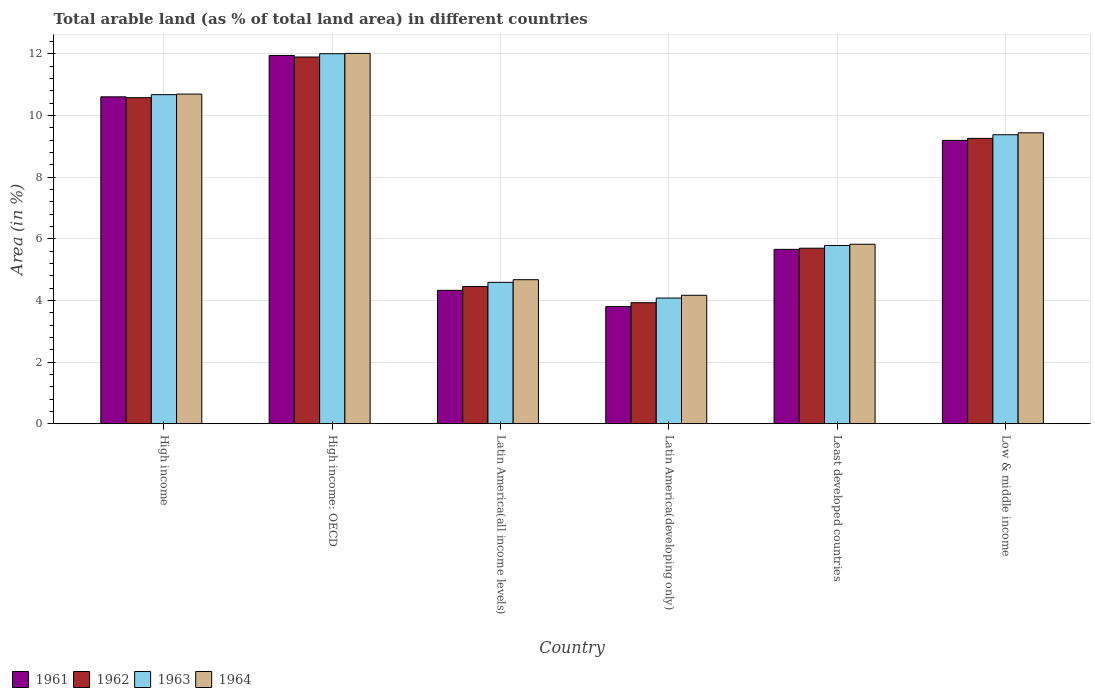How many bars are there on the 3rd tick from the left?
Keep it short and to the point. 4. What is the label of the 5th group of bars from the left?
Provide a short and direct response. Least developed countries. In how many cases, is the number of bars for a given country not equal to the number of legend labels?
Provide a short and direct response. 0. What is the percentage of arable land in 1961 in Latin America(all income levels)?
Provide a short and direct response. 4.33. Across all countries, what is the maximum percentage of arable land in 1962?
Your answer should be compact. 11.9. Across all countries, what is the minimum percentage of arable land in 1961?
Give a very brief answer. 3.8. In which country was the percentage of arable land in 1963 maximum?
Make the answer very short. High income: OECD. In which country was the percentage of arable land in 1962 minimum?
Offer a very short reply. Latin America(developing only). What is the total percentage of arable land in 1961 in the graph?
Your response must be concise. 45.54. What is the difference between the percentage of arable land in 1961 in High income and that in Low & middle income?
Give a very brief answer. 1.41. What is the difference between the percentage of arable land in 1964 in Latin America(developing only) and the percentage of arable land in 1961 in Least developed countries?
Provide a succinct answer. -1.49. What is the average percentage of arable land in 1961 per country?
Keep it short and to the point. 7.59. What is the difference between the percentage of arable land of/in 1961 and percentage of arable land of/in 1964 in High income?
Your response must be concise. -0.09. What is the ratio of the percentage of arable land in 1961 in High income: OECD to that in Low & middle income?
Make the answer very short. 1.3. Is the percentage of arable land in 1962 in Latin America(developing only) less than that in Low & middle income?
Give a very brief answer. Yes. Is the difference between the percentage of arable land in 1961 in Least developed countries and Low & middle income greater than the difference between the percentage of arable land in 1964 in Least developed countries and Low & middle income?
Ensure brevity in your answer.  Yes. What is the difference between the highest and the second highest percentage of arable land in 1964?
Your answer should be compact. -1.26. What is the difference between the highest and the lowest percentage of arable land in 1962?
Your answer should be very brief. 7.97. In how many countries, is the percentage of arable land in 1963 greater than the average percentage of arable land in 1963 taken over all countries?
Offer a terse response. 3. Is it the case that in every country, the sum of the percentage of arable land in 1962 and percentage of arable land in 1963 is greater than the sum of percentage of arable land in 1964 and percentage of arable land in 1961?
Offer a terse response. No. What does the 1st bar from the right in Least developed countries represents?
Offer a very short reply. 1964. Is it the case that in every country, the sum of the percentage of arable land in 1963 and percentage of arable land in 1961 is greater than the percentage of arable land in 1964?
Provide a succinct answer. Yes. How many countries are there in the graph?
Your answer should be compact. 6. Does the graph contain grids?
Keep it short and to the point. Yes. Where does the legend appear in the graph?
Your response must be concise. Bottom left. How many legend labels are there?
Provide a short and direct response. 4. What is the title of the graph?
Give a very brief answer. Total arable land (as % of total land area) in different countries. Does "1987" appear as one of the legend labels in the graph?
Your answer should be compact. No. What is the label or title of the Y-axis?
Keep it short and to the point. Area (in %). What is the Area (in %) of 1961 in High income?
Your answer should be very brief. 10.61. What is the Area (in %) in 1962 in High income?
Your response must be concise. 10.58. What is the Area (in %) in 1963 in High income?
Offer a terse response. 10.68. What is the Area (in %) of 1964 in High income?
Provide a short and direct response. 10.7. What is the Area (in %) in 1961 in High income: OECD?
Ensure brevity in your answer.  11.95. What is the Area (in %) of 1962 in High income: OECD?
Keep it short and to the point. 11.9. What is the Area (in %) of 1963 in High income: OECD?
Your answer should be very brief. 12.01. What is the Area (in %) in 1964 in High income: OECD?
Your response must be concise. 12.02. What is the Area (in %) in 1961 in Latin America(all income levels)?
Make the answer very short. 4.33. What is the Area (in %) in 1962 in Latin America(all income levels)?
Provide a succinct answer. 4.45. What is the Area (in %) of 1963 in Latin America(all income levels)?
Give a very brief answer. 4.59. What is the Area (in %) in 1964 in Latin America(all income levels)?
Make the answer very short. 4.67. What is the Area (in %) of 1961 in Latin America(developing only)?
Provide a succinct answer. 3.8. What is the Area (in %) of 1962 in Latin America(developing only)?
Provide a succinct answer. 3.93. What is the Area (in %) in 1963 in Latin America(developing only)?
Your answer should be compact. 4.08. What is the Area (in %) of 1964 in Latin America(developing only)?
Give a very brief answer. 4.17. What is the Area (in %) in 1961 in Least developed countries?
Make the answer very short. 5.66. What is the Area (in %) of 1962 in Least developed countries?
Ensure brevity in your answer.  5.7. What is the Area (in %) of 1963 in Least developed countries?
Provide a short and direct response. 5.78. What is the Area (in %) in 1964 in Least developed countries?
Make the answer very short. 5.82. What is the Area (in %) of 1961 in Low & middle income?
Make the answer very short. 9.19. What is the Area (in %) in 1962 in Low & middle income?
Your answer should be compact. 9.26. What is the Area (in %) in 1963 in Low & middle income?
Provide a succinct answer. 9.38. What is the Area (in %) in 1964 in Low & middle income?
Offer a terse response. 9.44. Across all countries, what is the maximum Area (in %) in 1961?
Give a very brief answer. 11.95. Across all countries, what is the maximum Area (in %) in 1962?
Give a very brief answer. 11.9. Across all countries, what is the maximum Area (in %) in 1963?
Offer a terse response. 12.01. Across all countries, what is the maximum Area (in %) in 1964?
Ensure brevity in your answer.  12.02. Across all countries, what is the minimum Area (in %) in 1961?
Make the answer very short. 3.8. Across all countries, what is the minimum Area (in %) of 1962?
Offer a terse response. 3.93. Across all countries, what is the minimum Area (in %) in 1963?
Your answer should be very brief. 4.08. Across all countries, what is the minimum Area (in %) of 1964?
Offer a very short reply. 4.17. What is the total Area (in %) of 1961 in the graph?
Keep it short and to the point. 45.54. What is the total Area (in %) of 1962 in the graph?
Give a very brief answer. 45.82. What is the total Area (in %) of 1963 in the graph?
Offer a terse response. 46.51. What is the total Area (in %) of 1964 in the graph?
Provide a succinct answer. 46.82. What is the difference between the Area (in %) in 1961 in High income and that in High income: OECD?
Your answer should be compact. -1.34. What is the difference between the Area (in %) of 1962 in High income and that in High income: OECD?
Your answer should be very brief. -1.32. What is the difference between the Area (in %) in 1963 in High income and that in High income: OECD?
Provide a short and direct response. -1.33. What is the difference between the Area (in %) in 1964 in High income and that in High income: OECD?
Ensure brevity in your answer.  -1.32. What is the difference between the Area (in %) in 1961 in High income and that in Latin America(all income levels)?
Give a very brief answer. 6.28. What is the difference between the Area (in %) of 1962 in High income and that in Latin America(all income levels)?
Your response must be concise. 6.13. What is the difference between the Area (in %) in 1963 in High income and that in Latin America(all income levels)?
Provide a succinct answer. 6.09. What is the difference between the Area (in %) in 1964 in High income and that in Latin America(all income levels)?
Provide a short and direct response. 6.02. What is the difference between the Area (in %) of 1961 in High income and that in Latin America(developing only)?
Offer a very short reply. 6.81. What is the difference between the Area (in %) in 1962 in High income and that in Latin America(developing only)?
Give a very brief answer. 6.65. What is the difference between the Area (in %) of 1963 in High income and that in Latin America(developing only)?
Your response must be concise. 6.6. What is the difference between the Area (in %) in 1964 in High income and that in Latin America(developing only)?
Ensure brevity in your answer.  6.53. What is the difference between the Area (in %) in 1961 in High income and that in Least developed countries?
Your answer should be compact. 4.95. What is the difference between the Area (in %) of 1962 in High income and that in Least developed countries?
Keep it short and to the point. 4.88. What is the difference between the Area (in %) in 1963 in High income and that in Least developed countries?
Provide a short and direct response. 4.9. What is the difference between the Area (in %) in 1964 in High income and that in Least developed countries?
Provide a short and direct response. 4.87. What is the difference between the Area (in %) in 1961 in High income and that in Low & middle income?
Make the answer very short. 1.41. What is the difference between the Area (in %) of 1962 in High income and that in Low & middle income?
Make the answer very short. 1.32. What is the difference between the Area (in %) in 1963 in High income and that in Low & middle income?
Provide a succinct answer. 1.3. What is the difference between the Area (in %) of 1964 in High income and that in Low & middle income?
Your answer should be compact. 1.26. What is the difference between the Area (in %) in 1961 in High income: OECD and that in Latin America(all income levels)?
Your answer should be very brief. 7.62. What is the difference between the Area (in %) in 1962 in High income: OECD and that in Latin America(all income levels)?
Offer a terse response. 7.45. What is the difference between the Area (in %) of 1963 in High income: OECD and that in Latin America(all income levels)?
Make the answer very short. 7.42. What is the difference between the Area (in %) in 1964 in High income: OECD and that in Latin America(all income levels)?
Provide a succinct answer. 7.34. What is the difference between the Area (in %) in 1961 in High income: OECD and that in Latin America(developing only)?
Ensure brevity in your answer.  8.15. What is the difference between the Area (in %) of 1962 in High income: OECD and that in Latin America(developing only)?
Your answer should be compact. 7.97. What is the difference between the Area (in %) in 1963 in High income: OECD and that in Latin America(developing only)?
Ensure brevity in your answer.  7.93. What is the difference between the Area (in %) of 1964 in High income: OECD and that in Latin America(developing only)?
Give a very brief answer. 7.85. What is the difference between the Area (in %) of 1961 in High income: OECD and that in Least developed countries?
Keep it short and to the point. 6.29. What is the difference between the Area (in %) in 1962 in High income: OECD and that in Least developed countries?
Keep it short and to the point. 6.2. What is the difference between the Area (in %) in 1963 in High income: OECD and that in Least developed countries?
Your answer should be compact. 6.22. What is the difference between the Area (in %) of 1964 in High income: OECD and that in Least developed countries?
Keep it short and to the point. 6.19. What is the difference between the Area (in %) in 1961 in High income: OECD and that in Low & middle income?
Provide a succinct answer. 2.76. What is the difference between the Area (in %) of 1962 in High income: OECD and that in Low & middle income?
Your answer should be compact. 2.64. What is the difference between the Area (in %) in 1963 in High income: OECD and that in Low & middle income?
Your response must be concise. 2.63. What is the difference between the Area (in %) in 1964 in High income: OECD and that in Low & middle income?
Your response must be concise. 2.58. What is the difference between the Area (in %) of 1961 in Latin America(all income levels) and that in Latin America(developing only)?
Your answer should be compact. 0.53. What is the difference between the Area (in %) in 1962 in Latin America(all income levels) and that in Latin America(developing only)?
Provide a short and direct response. 0.52. What is the difference between the Area (in %) in 1963 in Latin America(all income levels) and that in Latin America(developing only)?
Provide a short and direct response. 0.51. What is the difference between the Area (in %) in 1964 in Latin America(all income levels) and that in Latin America(developing only)?
Your response must be concise. 0.51. What is the difference between the Area (in %) in 1961 in Latin America(all income levels) and that in Least developed countries?
Ensure brevity in your answer.  -1.33. What is the difference between the Area (in %) in 1962 in Latin America(all income levels) and that in Least developed countries?
Provide a short and direct response. -1.24. What is the difference between the Area (in %) of 1963 in Latin America(all income levels) and that in Least developed countries?
Keep it short and to the point. -1.2. What is the difference between the Area (in %) of 1964 in Latin America(all income levels) and that in Least developed countries?
Provide a short and direct response. -1.15. What is the difference between the Area (in %) of 1961 in Latin America(all income levels) and that in Low & middle income?
Provide a succinct answer. -4.87. What is the difference between the Area (in %) of 1962 in Latin America(all income levels) and that in Low & middle income?
Provide a succinct answer. -4.81. What is the difference between the Area (in %) of 1963 in Latin America(all income levels) and that in Low & middle income?
Make the answer very short. -4.79. What is the difference between the Area (in %) of 1964 in Latin America(all income levels) and that in Low & middle income?
Make the answer very short. -4.77. What is the difference between the Area (in %) of 1961 in Latin America(developing only) and that in Least developed countries?
Your answer should be compact. -1.86. What is the difference between the Area (in %) in 1962 in Latin America(developing only) and that in Least developed countries?
Make the answer very short. -1.77. What is the difference between the Area (in %) in 1963 in Latin America(developing only) and that in Least developed countries?
Give a very brief answer. -1.71. What is the difference between the Area (in %) in 1964 in Latin America(developing only) and that in Least developed countries?
Offer a very short reply. -1.66. What is the difference between the Area (in %) in 1961 in Latin America(developing only) and that in Low & middle income?
Offer a terse response. -5.39. What is the difference between the Area (in %) in 1962 in Latin America(developing only) and that in Low & middle income?
Offer a terse response. -5.33. What is the difference between the Area (in %) of 1963 in Latin America(developing only) and that in Low & middle income?
Offer a very short reply. -5.3. What is the difference between the Area (in %) of 1964 in Latin America(developing only) and that in Low & middle income?
Ensure brevity in your answer.  -5.27. What is the difference between the Area (in %) in 1961 in Least developed countries and that in Low & middle income?
Ensure brevity in your answer.  -3.54. What is the difference between the Area (in %) in 1962 in Least developed countries and that in Low & middle income?
Offer a very short reply. -3.56. What is the difference between the Area (in %) of 1963 in Least developed countries and that in Low & middle income?
Make the answer very short. -3.59. What is the difference between the Area (in %) of 1964 in Least developed countries and that in Low & middle income?
Offer a very short reply. -3.62. What is the difference between the Area (in %) in 1961 in High income and the Area (in %) in 1962 in High income: OECD?
Provide a short and direct response. -1.29. What is the difference between the Area (in %) of 1961 in High income and the Area (in %) of 1963 in High income: OECD?
Make the answer very short. -1.4. What is the difference between the Area (in %) in 1961 in High income and the Area (in %) in 1964 in High income: OECD?
Your answer should be very brief. -1.41. What is the difference between the Area (in %) in 1962 in High income and the Area (in %) in 1963 in High income: OECD?
Make the answer very short. -1.43. What is the difference between the Area (in %) in 1962 in High income and the Area (in %) in 1964 in High income: OECD?
Ensure brevity in your answer.  -1.44. What is the difference between the Area (in %) in 1963 in High income and the Area (in %) in 1964 in High income: OECD?
Ensure brevity in your answer.  -1.34. What is the difference between the Area (in %) in 1961 in High income and the Area (in %) in 1962 in Latin America(all income levels)?
Your answer should be compact. 6.16. What is the difference between the Area (in %) of 1961 in High income and the Area (in %) of 1963 in Latin America(all income levels)?
Your response must be concise. 6.02. What is the difference between the Area (in %) of 1961 in High income and the Area (in %) of 1964 in Latin America(all income levels)?
Ensure brevity in your answer.  5.93. What is the difference between the Area (in %) of 1962 in High income and the Area (in %) of 1963 in Latin America(all income levels)?
Your answer should be very brief. 5.99. What is the difference between the Area (in %) in 1962 in High income and the Area (in %) in 1964 in Latin America(all income levels)?
Your answer should be very brief. 5.91. What is the difference between the Area (in %) in 1963 in High income and the Area (in %) in 1964 in Latin America(all income levels)?
Keep it short and to the point. 6. What is the difference between the Area (in %) in 1961 in High income and the Area (in %) in 1962 in Latin America(developing only)?
Make the answer very short. 6.68. What is the difference between the Area (in %) in 1961 in High income and the Area (in %) in 1963 in Latin America(developing only)?
Give a very brief answer. 6.53. What is the difference between the Area (in %) in 1961 in High income and the Area (in %) in 1964 in Latin America(developing only)?
Your response must be concise. 6.44. What is the difference between the Area (in %) of 1962 in High income and the Area (in %) of 1963 in Latin America(developing only)?
Provide a short and direct response. 6.5. What is the difference between the Area (in %) of 1962 in High income and the Area (in %) of 1964 in Latin America(developing only)?
Give a very brief answer. 6.41. What is the difference between the Area (in %) in 1963 in High income and the Area (in %) in 1964 in Latin America(developing only)?
Your answer should be compact. 6.51. What is the difference between the Area (in %) of 1961 in High income and the Area (in %) of 1962 in Least developed countries?
Give a very brief answer. 4.91. What is the difference between the Area (in %) of 1961 in High income and the Area (in %) of 1963 in Least developed countries?
Ensure brevity in your answer.  4.82. What is the difference between the Area (in %) of 1961 in High income and the Area (in %) of 1964 in Least developed countries?
Your answer should be compact. 4.78. What is the difference between the Area (in %) of 1962 in High income and the Area (in %) of 1963 in Least developed countries?
Your response must be concise. 4.8. What is the difference between the Area (in %) of 1962 in High income and the Area (in %) of 1964 in Least developed countries?
Give a very brief answer. 4.76. What is the difference between the Area (in %) in 1963 in High income and the Area (in %) in 1964 in Least developed countries?
Keep it short and to the point. 4.86. What is the difference between the Area (in %) of 1961 in High income and the Area (in %) of 1962 in Low & middle income?
Ensure brevity in your answer.  1.35. What is the difference between the Area (in %) in 1961 in High income and the Area (in %) in 1963 in Low & middle income?
Your answer should be compact. 1.23. What is the difference between the Area (in %) in 1961 in High income and the Area (in %) in 1964 in Low & middle income?
Give a very brief answer. 1.17. What is the difference between the Area (in %) in 1962 in High income and the Area (in %) in 1963 in Low & middle income?
Your answer should be very brief. 1.2. What is the difference between the Area (in %) in 1962 in High income and the Area (in %) in 1964 in Low & middle income?
Provide a short and direct response. 1.14. What is the difference between the Area (in %) of 1963 in High income and the Area (in %) of 1964 in Low & middle income?
Offer a terse response. 1.24. What is the difference between the Area (in %) of 1961 in High income: OECD and the Area (in %) of 1962 in Latin America(all income levels)?
Keep it short and to the point. 7.5. What is the difference between the Area (in %) in 1961 in High income: OECD and the Area (in %) in 1963 in Latin America(all income levels)?
Give a very brief answer. 7.36. What is the difference between the Area (in %) of 1961 in High income: OECD and the Area (in %) of 1964 in Latin America(all income levels)?
Provide a succinct answer. 7.28. What is the difference between the Area (in %) in 1962 in High income: OECD and the Area (in %) in 1963 in Latin America(all income levels)?
Make the answer very short. 7.31. What is the difference between the Area (in %) of 1962 in High income: OECD and the Area (in %) of 1964 in Latin America(all income levels)?
Your answer should be very brief. 7.23. What is the difference between the Area (in %) of 1963 in High income: OECD and the Area (in %) of 1964 in Latin America(all income levels)?
Your answer should be compact. 7.33. What is the difference between the Area (in %) of 1961 in High income: OECD and the Area (in %) of 1962 in Latin America(developing only)?
Your answer should be very brief. 8.02. What is the difference between the Area (in %) in 1961 in High income: OECD and the Area (in %) in 1963 in Latin America(developing only)?
Your answer should be very brief. 7.87. What is the difference between the Area (in %) in 1961 in High income: OECD and the Area (in %) in 1964 in Latin America(developing only)?
Keep it short and to the point. 7.78. What is the difference between the Area (in %) of 1962 in High income: OECD and the Area (in %) of 1963 in Latin America(developing only)?
Ensure brevity in your answer.  7.82. What is the difference between the Area (in %) in 1962 in High income: OECD and the Area (in %) in 1964 in Latin America(developing only)?
Offer a very short reply. 7.73. What is the difference between the Area (in %) in 1963 in High income: OECD and the Area (in %) in 1964 in Latin America(developing only)?
Offer a very short reply. 7.84. What is the difference between the Area (in %) in 1961 in High income: OECD and the Area (in %) in 1962 in Least developed countries?
Your answer should be compact. 6.25. What is the difference between the Area (in %) of 1961 in High income: OECD and the Area (in %) of 1963 in Least developed countries?
Make the answer very short. 6.17. What is the difference between the Area (in %) of 1961 in High income: OECD and the Area (in %) of 1964 in Least developed countries?
Keep it short and to the point. 6.13. What is the difference between the Area (in %) in 1962 in High income: OECD and the Area (in %) in 1963 in Least developed countries?
Keep it short and to the point. 6.12. What is the difference between the Area (in %) of 1962 in High income: OECD and the Area (in %) of 1964 in Least developed countries?
Offer a terse response. 6.08. What is the difference between the Area (in %) of 1963 in High income: OECD and the Area (in %) of 1964 in Least developed countries?
Your answer should be compact. 6.18. What is the difference between the Area (in %) of 1961 in High income: OECD and the Area (in %) of 1962 in Low & middle income?
Your answer should be very brief. 2.69. What is the difference between the Area (in %) of 1961 in High income: OECD and the Area (in %) of 1963 in Low & middle income?
Your answer should be very brief. 2.57. What is the difference between the Area (in %) of 1961 in High income: OECD and the Area (in %) of 1964 in Low & middle income?
Offer a very short reply. 2.51. What is the difference between the Area (in %) of 1962 in High income: OECD and the Area (in %) of 1963 in Low & middle income?
Provide a succinct answer. 2.52. What is the difference between the Area (in %) in 1962 in High income: OECD and the Area (in %) in 1964 in Low & middle income?
Keep it short and to the point. 2.46. What is the difference between the Area (in %) of 1963 in High income: OECD and the Area (in %) of 1964 in Low & middle income?
Make the answer very short. 2.57. What is the difference between the Area (in %) of 1961 in Latin America(all income levels) and the Area (in %) of 1962 in Latin America(developing only)?
Give a very brief answer. 0.4. What is the difference between the Area (in %) of 1961 in Latin America(all income levels) and the Area (in %) of 1963 in Latin America(developing only)?
Offer a terse response. 0.25. What is the difference between the Area (in %) in 1961 in Latin America(all income levels) and the Area (in %) in 1964 in Latin America(developing only)?
Provide a succinct answer. 0.16. What is the difference between the Area (in %) of 1962 in Latin America(all income levels) and the Area (in %) of 1963 in Latin America(developing only)?
Keep it short and to the point. 0.37. What is the difference between the Area (in %) of 1962 in Latin America(all income levels) and the Area (in %) of 1964 in Latin America(developing only)?
Ensure brevity in your answer.  0.28. What is the difference between the Area (in %) of 1963 in Latin America(all income levels) and the Area (in %) of 1964 in Latin America(developing only)?
Offer a terse response. 0.42. What is the difference between the Area (in %) of 1961 in Latin America(all income levels) and the Area (in %) of 1962 in Least developed countries?
Offer a terse response. -1.37. What is the difference between the Area (in %) in 1961 in Latin America(all income levels) and the Area (in %) in 1963 in Least developed countries?
Provide a succinct answer. -1.46. What is the difference between the Area (in %) in 1961 in Latin America(all income levels) and the Area (in %) in 1964 in Least developed countries?
Keep it short and to the point. -1.5. What is the difference between the Area (in %) of 1962 in Latin America(all income levels) and the Area (in %) of 1963 in Least developed countries?
Offer a terse response. -1.33. What is the difference between the Area (in %) in 1962 in Latin America(all income levels) and the Area (in %) in 1964 in Least developed countries?
Provide a succinct answer. -1.37. What is the difference between the Area (in %) in 1963 in Latin America(all income levels) and the Area (in %) in 1964 in Least developed countries?
Keep it short and to the point. -1.24. What is the difference between the Area (in %) in 1961 in Latin America(all income levels) and the Area (in %) in 1962 in Low & middle income?
Provide a short and direct response. -4.93. What is the difference between the Area (in %) in 1961 in Latin America(all income levels) and the Area (in %) in 1963 in Low & middle income?
Give a very brief answer. -5.05. What is the difference between the Area (in %) in 1961 in Latin America(all income levels) and the Area (in %) in 1964 in Low & middle income?
Provide a short and direct response. -5.11. What is the difference between the Area (in %) in 1962 in Latin America(all income levels) and the Area (in %) in 1963 in Low & middle income?
Offer a terse response. -4.93. What is the difference between the Area (in %) of 1962 in Latin America(all income levels) and the Area (in %) of 1964 in Low & middle income?
Your response must be concise. -4.99. What is the difference between the Area (in %) in 1963 in Latin America(all income levels) and the Area (in %) in 1964 in Low & middle income?
Keep it short and to the point. -4.85. What is the difference between the Area (in %) of 1961 in Latin America(developing only) and the Area (in %) of 1962 in Least developed countries?
Offer a very short reply. -1.89. What is the difference between the Area (in %) in 1961 in Latin America(developing only) and the Area (in %) in 1963 in Least developed countries?
Your response must be concise. -1.98. What is the difference between the Area (in %) in 1961 in Latin America(developing only) and the Area (in %) in 1964 in Least developed countries?
Your response must be concise. -2.02. What is the difference between the Area (in %) of 1962 in Latin America(developing only) and the Area (in %) of 1963 in Least developed countries?
Your answer should be very brief. -1.86. What is the difference between the Area (in %) of 1962 in Latin America(developing only) and the Area (in %) of 1964 in Least developed countries?
Your answer should be compact. -1.9. What is the difference between the Area (in %) in 1963 in Latin America(developing only) and the Area (in %) in 1964 in Least developed countries?
Give a very brief answer. -1.75. What is the difference between the Area (in %) of 1961 in Latin America(developing only) and the Area (in %) of 1962 in Low & middle income?
Make the answer very short. -5.46. What is the difference between the Area (in %) of 1961 in Latin America(developing only) and the Area (in %) of 1963 in Low & middle income?
Provide a short and direct response. -5.58. What is the difference between the Area (in %) of 1961 in Latin America(developing only) and the Area (in %) of 1964 in Low & middle income?
Offer a very short reply. -5.64. What is the difference between the Area (in %) in 1962 in Latin America(developing only) and the Area (in %) in 1963 in Low & middle income?
Ensure brevity in your answer.  -5.45. What is the difference between the Area (in %) in 1962 in Latin America(developing only) and the Area (in %) in 1964 in Low & middle income?
Offer a terse response. -5.51. What is the difference between the Area (in %) of 1963 in Latin America(developing only) and the Area (in %) of 1964 in Low & middle income?
Provide a succinct answer. -5.36. What is the difference between the Area (in %) of 1961 in Least developed countries and the Area (in %) of 1962 in Low & middle income?
Ensure brevity in your answer.  -3.6. What is the difference between the Area (in %) in 1961 in Least developed countries and the Area (in %) in 1963 in Low & middle income?
Provide a short and direct response. -3.72. What is the difference between the Area (in %) of 1961 in Least developed countries and the Area (in %) of 1964 in Low & middle income?
Give a very brief answer. -3.78. What is the difference between the Area (in %) in 1962 in Least developed countries and the Area (in %) in 1963 in Low & middle income?
Your response must be concise. -3.68. What is the difference between the Area (in %) of 1962 in Least developed countries and the Area (in %) of 1964 in Low & middle income?
Offer a terse response. -3.74. What is the difference between the Area (in %) of 1963 in Least developed countries and the Area (in %) of 1964 in Low & middle income?
Give a very brief answer. -3.66. What is the average Area (in %) of 1961 per country?
Keep it short and to the point. 7.59. What is the average Area (in %) in 1962 per country?
Your response must be concise. 7.64. What is the average Area (in %) in 1963 per country?
Make the answer very short. 7.75. What is the average Area (in %) in 1964 per country?
Offer a terse response. 7.8. What is the difference between the Area (in %) in 1961 and Area (in %) in 1962 in High income?
Your answer should be compact. 0.03. What is the difference between the Area (in %) in 1961 and Area (in %) in 1963 in High income?
Provide a succinct answer. -0.07. What is the difference between the Area (in %) in 1961 and Area (in %) in 1964 in High income?
Give a very brief answer. -0.09. What is the difference between the Area (in %) of 1962 and Area (in %) of 1963 in High income?
Give a very brief answer. -0.1. What is the difference between the Area (in %) in 1962 and Area (in %) in 1964 in High income?
Your response must be concise. -0.12. What is the difference between the Area (in %) of 1963 and Area (in %) of 1964 in High income?
Provide a succinct answer. -0.02. What is the difference between the Area (in %) in 1961 and Area (in %) in 1963 in High income: OECD?
Ensure brevity in your answer.  -0.06. What is the difference between the Area (in %) of 1961 and Area (in %) of 1964 in High income: OECD?
Keep it short and to the point. -0.07. What is the difference between the Area (in %) of 1962 and Area (in %) of 1963 in High income: OECD?
Offer a very short reply. -0.11. What is the difference between the Area (in %) in 1962 and Area (in %) in 1964 in High income: OECD?
Your response must be concise. -0.12. What is the difference between the Area (in %) of 1963 and Area (in %) of 1964 in High income: OECD?
Ensure brevity in your answer.  -0.01. What is the difference between the Area (in %) in 1961 and Area (in %) in 1962 in Latin America(all income levels)?
Provide a succinct answer. -0.12. What is the difference between the Area (in %) of 1961 and Area (in %) of 1963 in Latin America(all income levels)?
Keep it short and to the point. -0.26. What is the difference between the Area (in %) of 1961 and Area (in %) of 1964 in Latin America(all income levels)?
Offer a terse response. -0.35. What is the difference between the Area (in %) of 1962 and Area (in %) of 1963 in Latin America(all income levels)?
Give a very brief answer. -0.14. What is the difference between the Area (in %) in 1962 and Area (in %) in 1964 in Latin America(all income levels)?
Your answer should be compact. -0.22. What is the difference between the Area (in %) in 1963 and Area (in %) in 1964 in Latin America(all income levels)?
Ensure brevity in your answer.  -0.09. What is the difference between the Area (in %) of 1961 and Area (in %) of 1962 in Latin America(developing only)?
Offer a terse response. -0.12. What is the difference between the Area (in %) of 1961 and Area (in %) of 1963 in Latin America(developing only)?
Provide a succinct answer. -0.28. What is the difference between the Area (in %) of 1961 and Area (in %) of 1964 in Latin America(developing only)?
Make the answer very short. -0.37. What is the difference between the Area (in %) of 1962 and Area (in %) of 1963 in Latin America(developing only)?
Provide a succinct answer. -0.15. What is the difference between the Area (in %) in 1962 and Area (in %) in 1964 in Latin America(developing only)?
Your answer should be compact. -0.24. What is the difference between the Area (in %) of 1963 and Area (in %) of 1964 in Latin America(developing only)?
Your answer should be compact. -0.09. What is the difference between the Area (in %) of 1961 and Area (in %) of 1962 in Least developed countries?
Keep it short and to the point. -0.04. What is the difference between the Area (in %) in 1961 and Area (in %) in 1963 in Least developed countries?
Provide a succinct answer. -0.13. What is the difference between the Area (in %) in 1961 and Area (in %) in 1964 in Least developed countries?
Your answer should be very brief. -0.17. What is the difference between the Area (in %) of 1962 and Area (in %) of 1963 in Least developed countries?
Provide a succinct answer. -0.09. What is the difference between the Area (in %) of 1962 and Area (in %) of 1964 in Least developed countries?
Your answer should be compact. -0.13. What is the difference between the Area (in %) of 1963 and Area (in %) of 1964 in Least developed countries?
Ensure brevity in your answer.  -0.04. What is the difference between the Area (in %) in 1961 and Area (in %) in 1962 in Low & middle income?
Give a very brief answer. -0.07. What is the difference between the Area (in %) in 1961 and Area (in %) in 1963 in Low & middle income?
Offer a terse response. -0.18. What is the difference between the Area (in %) in 1961 and Area (in %) in 1964 in Low & middle income?
Ensure brevity in your answer.  -0.25. What is the difference between the Area (in %) in 1962 and Area (in %) in 1963 in Low & middle income?
Make the answer very short. -0.12. What is the difference between the Area (in %) of 1962 and Area (in %) of 1964 in Low & middle income?
Offer a very short reply. -0.18. What is the difference between the Area (in %) in 1963 and Area (in %) in 1964 in Low & middle income?
Provide a succinct answer. -0.06. What is the ratio of the Area (in %) of 1961 in High income to that in High income: OECD?
Your answer should be compact. 0.89. What is the ratio of the Area (in %) of 1962 in High income to that in High income: OECD?
Your response must be concise. 0.89. What is the ratio of the Area (in %) of 1963 in High income to that in High income: OECD?
Keep it short and to the point. 0.89. What is the ratio of the Area (in %) in 1964 in High income to that in High income: OECD?
Offer a very short reply. 0.89. What is the ratio of the Area (in %) in 1961 in High income to that in Latin America(all income levels)?
Your response must be concise. 2.45. What is the ratio of the Area (in %) of 1962 in High income to that in Latin America(all income levels)?
Give a very brief answer. 2.38. What is the ratio of the Area (in %) in 1963 in High income to that in Latin America(all income levels)?
Keep it short and to the point. 2.33. What is the ratio of the Area (in %) in 1964 in High income to that in Latin America(all income levels)?
Your response must be concise. 2.29. What is the ratio of the Area (in %) of 1961 in High income to that in Latin America(developing only)?
Your response must be concise. 2.79. What is the ratio of the Area (in %) of 1962 in High income to that in Latin America(developing only)?
Provide a short and direct response. 2.69. What is the ratio of the Area (in %) in 1963 in High income to that in Latin America(developing only)?
Offer a very short reply. 2.62. What is the ratio of the Area (in %) of 1964 in High income to that in Latin America(developing only)?
Your answer should be compact. 2.57. What is the ratio of the Area (in %) in 1961 in High income to that in Least developed countries?
Provide a short and direct response. 1.87. What is the ratio of the Area (in %) in 1962 in High income to that in Least developed countries?
Make the answer very short. 1.86. What is the ratio of the Area (in %) of 1963 in High income to that in Least developed countries?
Offer a terse response. 1.85. What is the ratio of the Area (in %) in 1964 in High income to that in Least developed countries?
Your response must be concise. 1.84. What is the ratio of the Area (in %) of 1961 in High income to that in Low & middle income?
Make the answer very short. 1.15. What is the ratio of the Area (in %) of 1962 in High income to that in Low & middle income?
Give a very brief answer. 1.14. What is the ratio of the Area (in %) in 1963 in High income to that in Low & middle income?
Provide a succinct answer. 1.14. What is the ratio of the Area (in %) of 1964 in High income to that in Low & middle income?
Offer a very short reply. 1.13. What is the ratio of the Area (in %) of 1961 in High income: OECD to that in Latin America(all income levels)?
Offer a terse response. 2.76. What is the ratio of the Area (in %) of 1962 in High income: OECD to that in Latin America(all income levels)?
Your answer should be very brief. 2.67. What is the ratio of the Area (in %) in 1963 in High income: OECD to that in Latin America(all income levels)?
Your response must be concise. 2.62. What is the ratio of the Area (in %) of 1964 in High income: OECD to that in Latin America(all income levels)?
Your answer should be compact. 2.57. What is the ratio of the Area (in %) in 1961 in High income: OECD to that in Latin America(developing only)?
Keep it short and to the point. 3.14. What is the ratio of the Area (in %) of 1962 in High income: OECD to that in Latin America(developing only)?
Provide a succinct answer. 3.03. What is the ratio of the Area (in %) in 1963 in High income: OECD to that in Latin America(developing only)?
Your answer should be very brief. 2.94. What is the ratio of the Area (in %) in 1964 in High income: OECD to that in Latin America(developing only)?
Make the answer very short. 2.88. What is the ratio of the Area (in %) of 1961 in High income: OECD to that in Least developed countries?
Your answer should be compact. 2.11. What is the ratio of the Area (in %) of 1962 in High income: OECD to that in Least developed countries?
Your answer should be compact. 2.09. What is the ratio of the Area (in %) of 1963 in High income: OECD to that in Least developed countries?
Offer a very short reply. 2.08. What is the ratio of the Area (in %) in 1964 in High income: OECD to that in Least developed countries?
Your answer should be very brief. 2.06. What is the ratio of the Area (in %) of 1961 in High income: OECD to that in Low & middle income?
Offer a very short reply. 1.3. What is the ratio of the Area (in %) in 1962 in High income: OECD to that in Low & middle income?
Provide a short and direct response. 1.29. What is the ratio of the Area (in %) in 1963 in High income: OECD to that in Low & middle income?
Your response must be concise. 1.28. What is the ratio of the Area (in %) of 1964 in High income: OECD to that in Low & middle income?
Offer a terse response. 1.27. What is the ratio of the Area (in %) of 1961 in Latin America(all income levels) to that in Latin America(developing only)?
Your answer should be compact. 1.14. What is the ratio of the Area (in %) of 1962 in Latin America(all income levels) to that in Latin America(developing only)?
Your response must be concise. 1.13. What is the ratio of the Area (in %) of 1963 in Latin America(all income levels) to that in Latin America(developing only)?
Offer a very short reply. 1.12. What is the ratio of the Area (in %) in 1964 in Latin America(all income levels) to that in Latin America(developing only)?
Offer a terse response. 1.12. What is the ratio of the Area (in %) in 1961 in Latin America(all income levels) to that in Least developed countries?
Provide a succinct answer. 0.77. What is the ratio of the Area (in %) of 1962 in Latin America(all income levels) to that in Least developed countries?
Your response must be concise. 0.78. What is the ratio of the Area (in %) of 1963 in Latin America(all income levels) to that in Least developed countries?
Offer a terse response. 0.79. What is the ratio of the Area (in %) of 1964 in Latin America(all income levels) to that in Least developed countries?
Your response must be concise. 0.8. What is the ratio of the Area (in %) of 1961 in Latin America(all income levels) to that in Low & middle income?
Provide a short and direct response. 0.47. What is the ratio of the Area (in %) of 1962 in Latin America(all income levels) to that in Low & middle income?
Provide a succinct answer. 0.48. What is the ratio of the Area (in %) of 1963 in Latin America(all income levels) to that in Low & middle income?
Offer a very short reply. 0.49. What is the ratio of the Area (in %) of 1964 in Latin America(all income levels) to that in Low & middle income?
Provide a succinct answer. 0.5. What is the ratio of the Area (in %) of 1961 in Latin America(developing only) to that in Least developed countries?
Provide a succinct answer. 0.67. What is the ratio of the Area (in %) in 1962 in Latin America(developing only) to that in Least developed countries?
Offer a terse response. 0.69. What is the ratio of the Area (in %) of 1963 in Latin America(developing only) to that in Least developed countries?
Make the answer very short. 0.71. What is the ratio of the Area (in %) in 1964 in Latin America(developing only) to that in Least developed countries?
Provide a short and direct response. 0.72. What is the ratio of the Area (in %) in 1961 in Latin America(developing only) to that in Low & middle income?
Offer a terse response. 0.41. What is the ratio of the Area (in %) of 1962 in Latin America(developing only) to that in Low & middle income?
Provide a short and direct response. 0.42. What is the ratio of the Area (in %) of 1963 in Latin America(developing only) to that in Low & middle income?
Offer a very short reply. 0.43. What is the ratio of the Area (in %) of 1964 in Latin America(developing only) to that in Low & middle income?
Give a very brief answer. 0.44. What is the ratio of the Area (in %) in 1961 in Least developed countries to that in Low & middle income?
Keep it short and to the point. 0.62. What is the ratio of the Area (in %) of 1962 in Least developed countries to that in Low & middle income?
Give a very brief answer. 0.62. What is the ratio of the Area (in %) in 1963 in Least developed countries to that in Low & middle income?
Give a very brief answer. 0.62. What is the ratio of the Area (in %) of 1964 in Least developed countries to that in Low & middle income?
Provide a short and direct response. 0.62. What is the difference between the highest and the second highest Area (in %) in 1961?
Give a very brief answer. 1.34. What is the difference between the highest and the second highest Area (in %) in 1962?
Offer a very short reply. 1.32. What is the difference between the highest and the second highest Area (in %) of 1963?
Provide a short and direct response. 1.33. What is the difference between the highest and the second highest Area (in %) of 1964?
Your answer should be very brief. 1.32. What is the difference between the highest and the lowest Area (in %) in 1961?
Your answer should be compact. 8.15. What is the difference between the highest and the lowest Area (in %) in 1962?
Make the answer very short. 7.97. What is the difference between the highest and the lowest Area (in %) in 1963?
Provide a succinct answer. 7.93. What is the difference between the highest and the lowest Area (in %) in 1964?
Your answer should be compact. 7.85. 